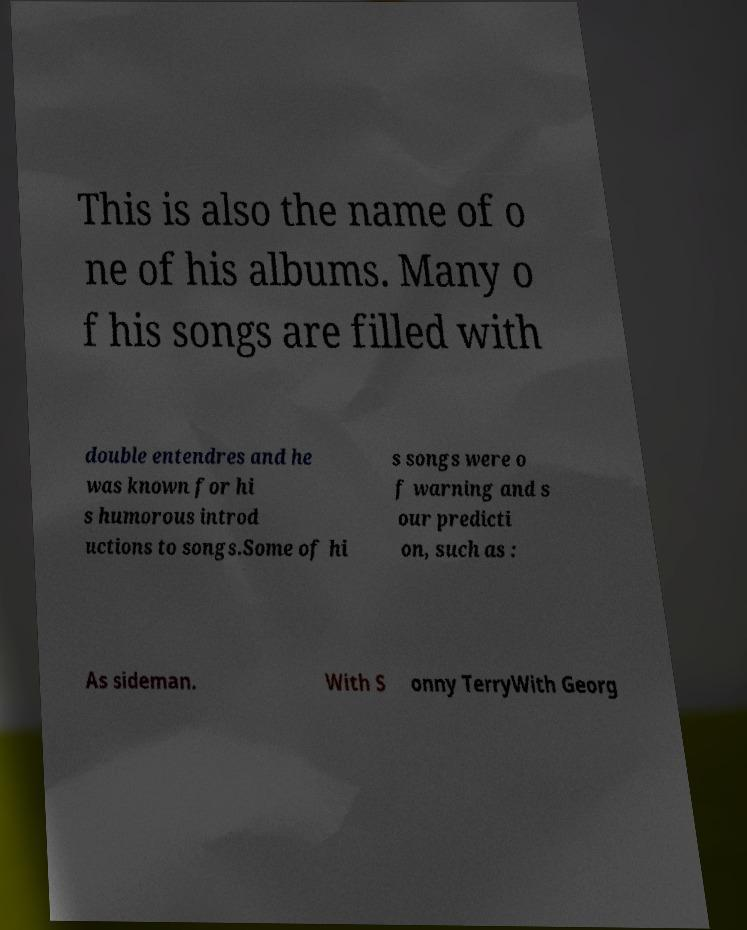Could you extract and type out the text from this image? This is also the name of o ne of his albums. Many o f his songs are filled with double entendres and he was known for hi s humorous introd uctions to songs.Some of hi s songs were o f warning and s our predicti on, such as : As sideman. With S onny TerryWith Georg 